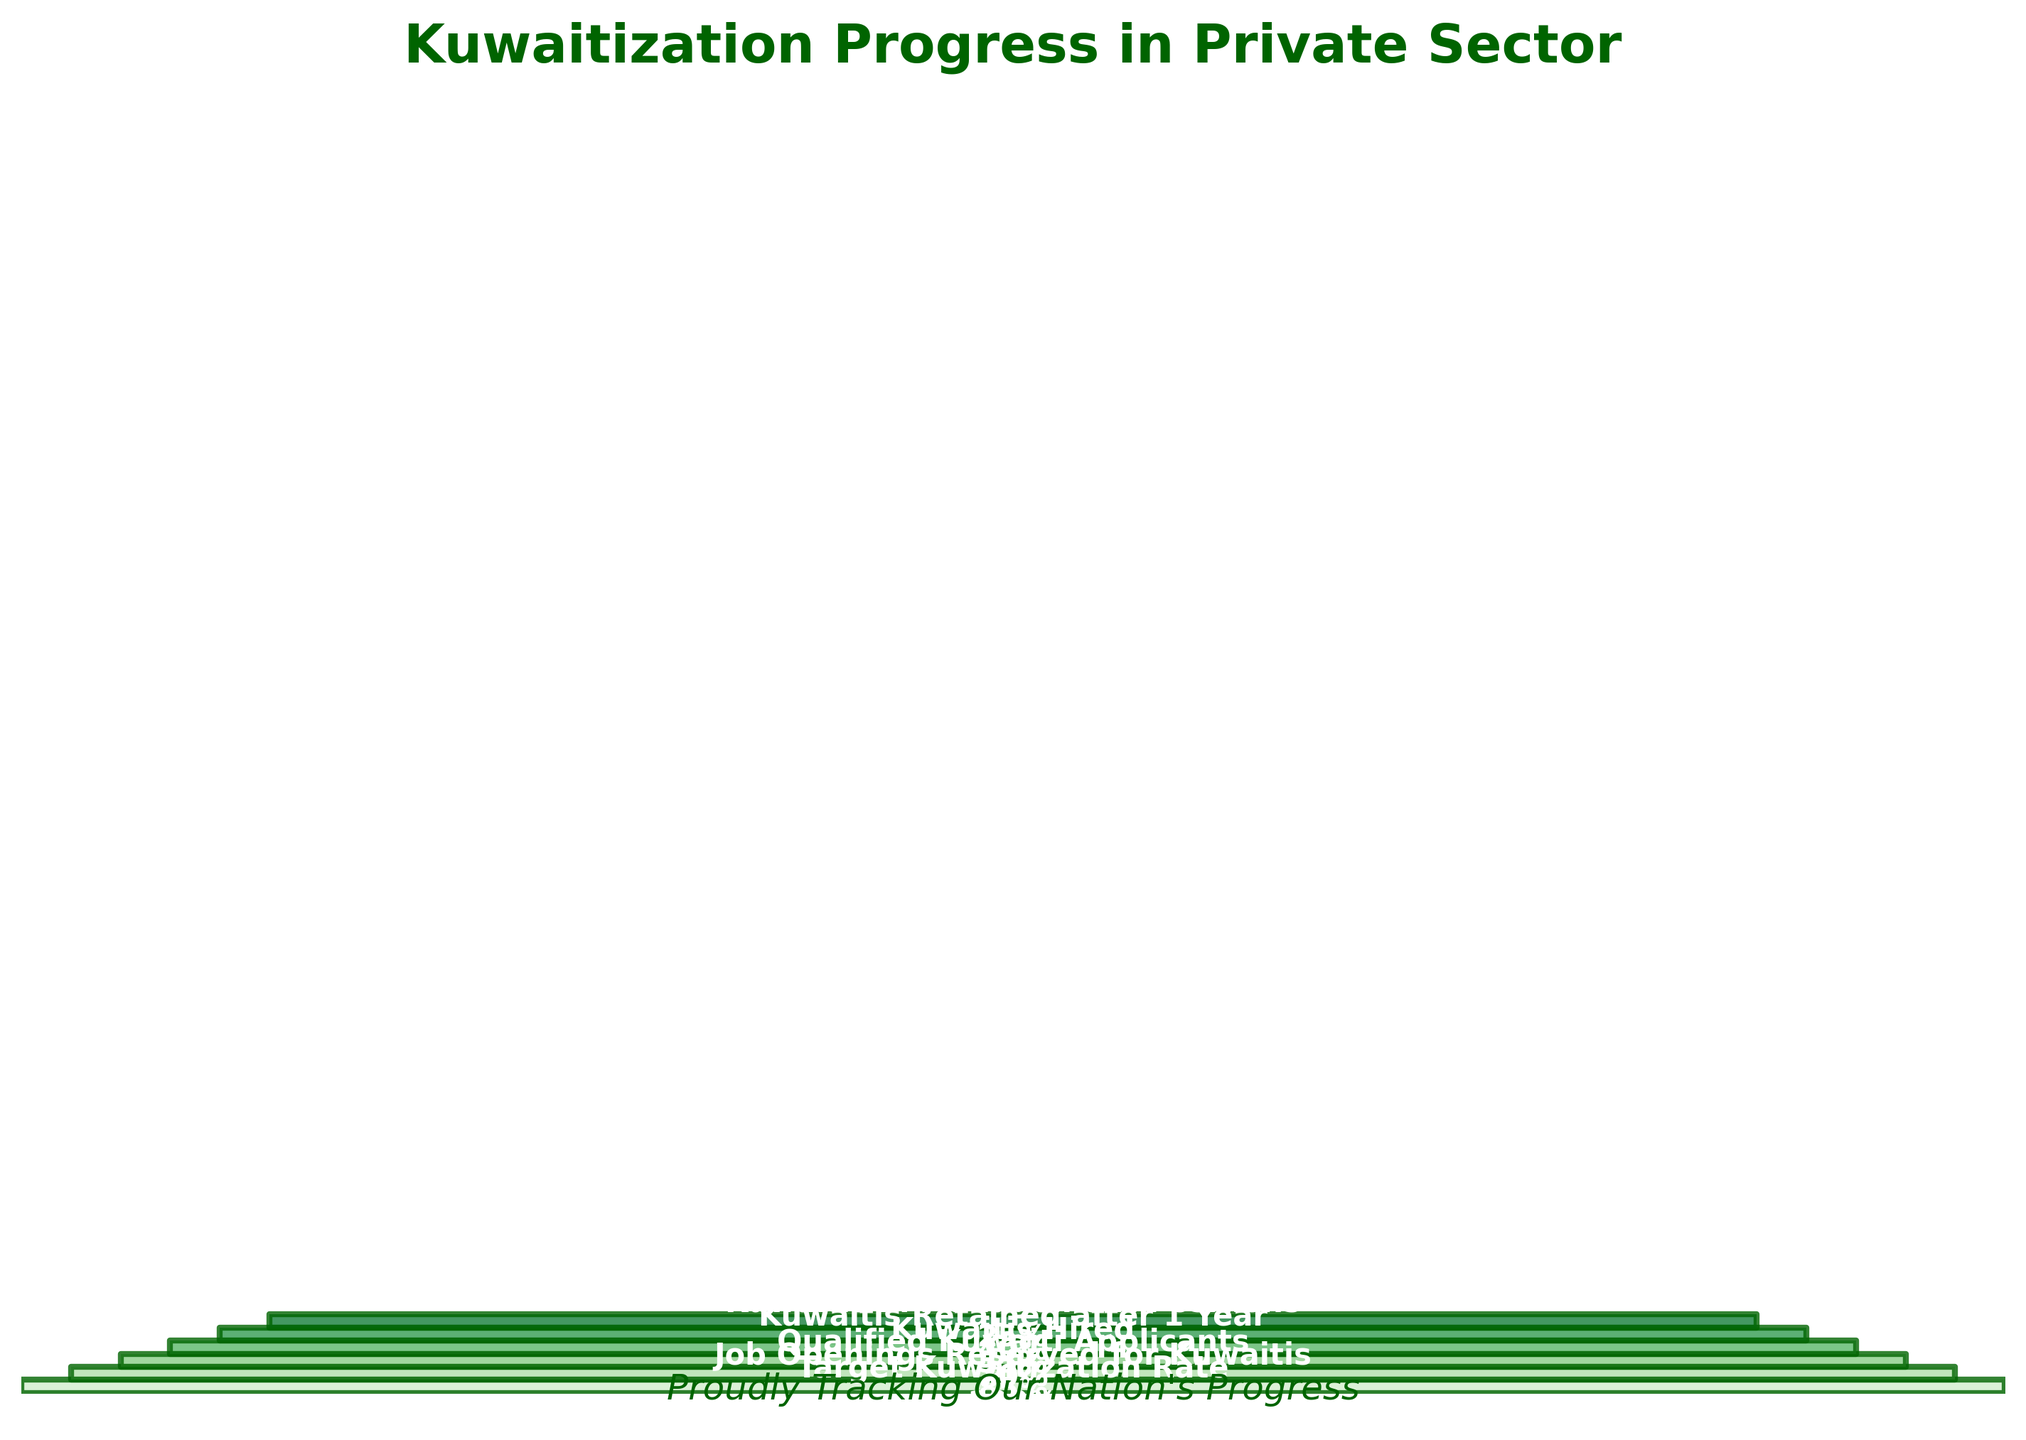What's the title of the funnel chart? The title is often displayed at the top of the chart and describes what it represents. In this case, it reads "Kuwaitization Progress in Private Sector".
Answer: Kuwaitization Progress in Private Sector How many stages are there in the Kuwaitization process shown in the chart? Count the number of unique stages listed along the y-axis or labeled on the chart itself. There are six stages listed from "Target Kuwaitization Rate" to "Kuwaitis in Management Positions".
Answer: 6 What percentage of job openings are reserved for Kuwaitis? Look at the segment labeled "Job Openings Reserved for Kuwaitis" and note the percentage value displayed within this segment.
Answer: 85% Which stage has the lowest percentage value and what is it? Find the shortest segment in the funnel, which represents the lowest percentage. The label for this segment is "Kuwaitis in Management Positions" with the percentage value of 25%.
Answer: Kuwaitis in Management Positions (25%) How much higher is the percentage of "Qualified Kuwaiti Applicants" compared to "Kuwaitis Hired"? Subtract the percentage for "Kuwaitis Hired" from "Qualified Kuwaiti Applicants": 70% - 55%.
Answer: 15% Which stages have a percentage below 50%? List them. Identify the stages with percentage values less than 50%. These are "Kuwaitis Hired" (55%), "Kuwaitis Retained after 1 Year" (40%), and "Kuwaitis in Management Positions" (25%).
Answer: Kuwaitis Retained after 1 Year, Kuwaitis in Management Positions What is the average percentage of the stages measured in the chart? Add up all the percentages (100 + 85 + 70 + 55 + 40 + 25) and divide by the number of stages (6): (100 + 85 + 70 + 55 + 40 + 25) / 6 = 62.5%.
Answer: 62.5% Compare the decline from "Kuwaitis Hired" to "Kuwaitis Retained after 1 Year" with the decline from "Qualified Kuwaiti Applicants" to "Kuwaitis Hired". Which is greater? Calculate both declines: From "Kuwaitis Hired" to "Kuwaitis Retained after 1 Year" it's 55% - 40% = 15%, and from "Qualified Kuwaiti Applicants" to "Kuwaitis Hired" it's 70% - 55% = 15%. Both declines are equal.
Answer: Both are equal (15%) What is the primary color scheme used in this funnel chart? The primary color scheme is identified based on the general hue used to fill the segments of the funnel chart. The colors vary from light green to dark green.
Answer: Green 